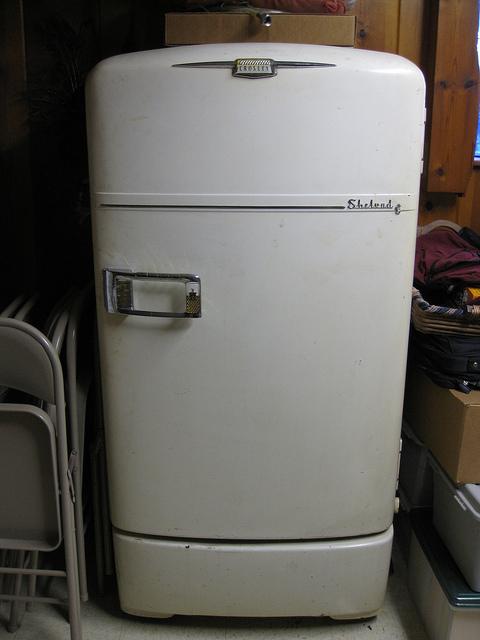In what room is the refrigerator stored?
Concise answer only. Kitchen. What brand of refrigerator is this?
Short answer required. Kimberly. How many handles do you see?
Write a very short answer. 1. Is the refrigerator new or old?
Quick response, please. Old. What brand is the refrigerator?
Be succinct. Frigidaire. 